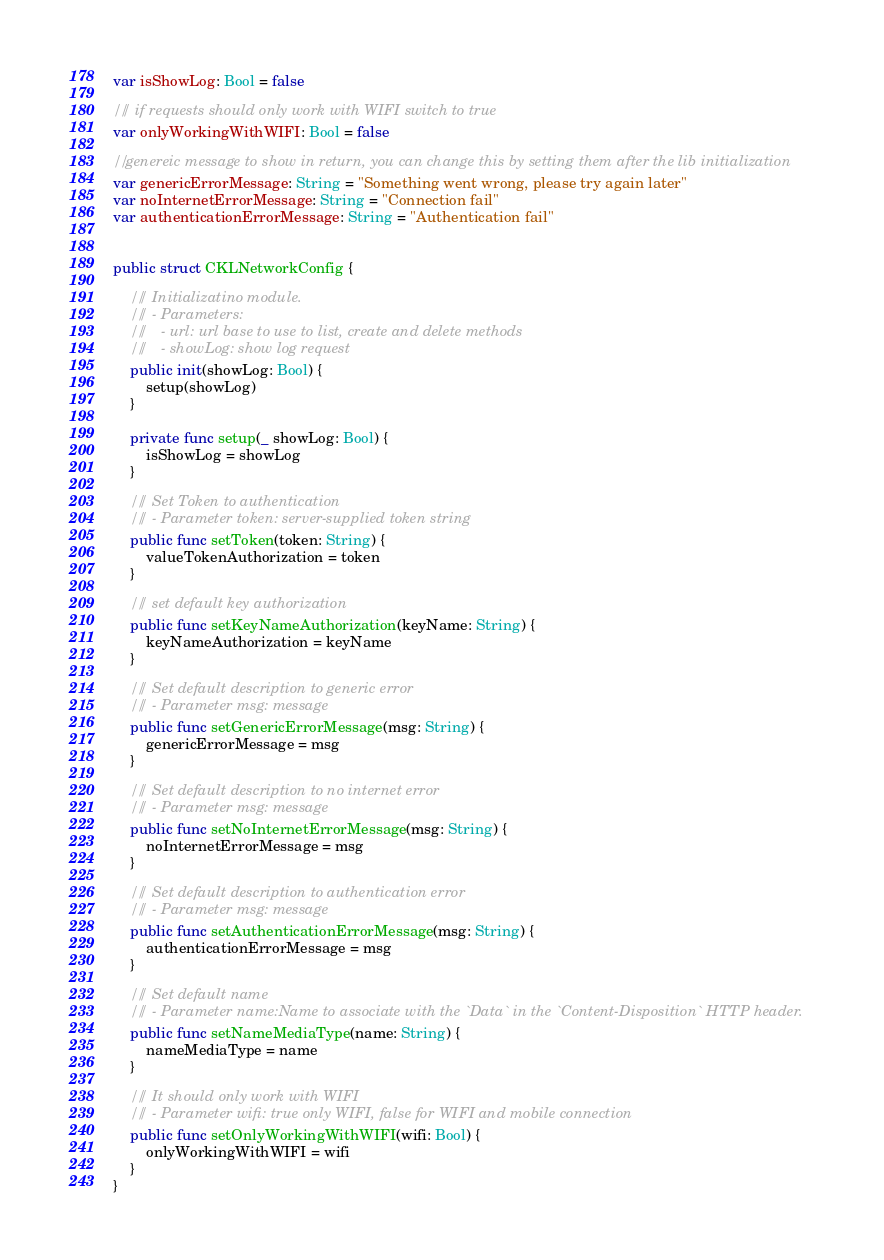<code> <loc_0><loc_0><loc_500><loc_500><_Swift_>var isShowLog: Bool = false

/// if requests should only work with WIFI switch to true
var onlyWorkingWithWIFI: Bool = false

// genereic message to show in return, you can change this by setting them after the lib initialization
var genericErrorMessage: String = "Something went wrong, please try again later"
var noInternetErrorMessage: String = "Connection fail"
var authenticationErrorMessage: String = "Authentication fail"


public struct CKLNetworkConfig {
    
    /// Initializatino module.
    /// - Parameters:
    ///   - url: url base to use to list, create and delete methods
    ///   - showLog: show log request
    public init(showLog: Bool) {
        setup(showLog)
    }
    
    private func setup(_ showLog: Bool) {
        isShowLog = showLog
    }
    
    /// Set Token to authentication
    /// - Parameter token: server-supplied token string
    public func setToken(token: String) {
        valueTokenAuthorization = token
    }
    
    /// set default key authorization
    public func setKeyNameAuthorization(keyName: String) {
        keyNameAuthorization = keyName
    }
    
    /// Set default description to generic error
    /// - Parameter msg: message
    public func setGenericErrorMessage(msg: String) {
        genericErrorMessage = msg
    }
    
    /// Set default description to no internet error
    /// - Parameter msg: message
    public func setNoInternetErrorMessage(msg: String) {
        noInternetErrorMessage = msg
    }
    
    /// Set default description to authentication error
    /// - Parameter msg: message
    public func setAuthenticationErrorMessage(msg: String) {
        authenticationErrorMessage = msg
    }
    
    /// Set default name
    /// - Parameter name:Name to associate with the `Data` in the `Content-Disposition` HTTP header.
    public func setNameMediaType(name: String) {
        nameMediaType = name
    }
    
    /// It should only work with WIFI
    /// - Parameter wifi: true only WIFI, false for WIFI and mobile connection
    public func setOnlyWorkingWithWIFI(wifi: Bool) {
        onlyWorkingWithWIFI = wifi
    }
}
</code> 